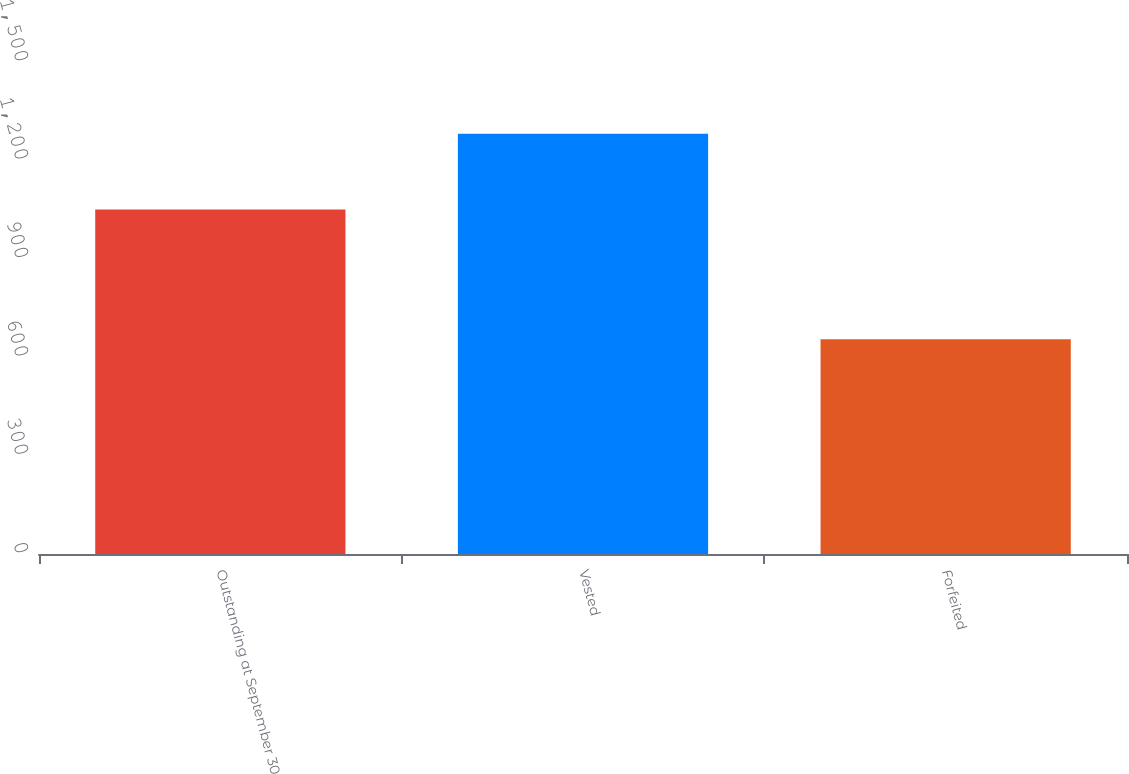Convert chart. <chart><loc_0><loc_0><loc_500><loc_500><bar_chart><fcel>Outstanding at September 30<fcel>Vested<fcel>Forfeited<nl><fcel>1050<fcel>1281.6<fcel>655<nl></chart> 